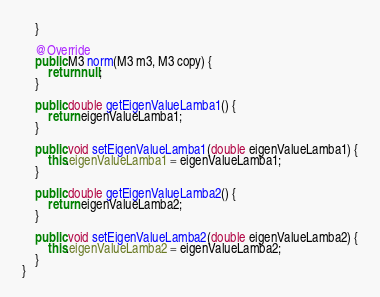Convert code to text. <code><loc_0><loc_0><loc_500><loc_500><_Java_>
    }

    @Override
    public M3 norm(M3 m3, M3 copy) {
        return null;
    }

    public double getEigenValueLamba1() {
        return eigenValueLamba1;
    }

    public void setEigenValueLamba1(double eigenValueLamba1) {
        this.eigenValueLamba1 = eigenValueLamba1;
    }

    public double getEigenValueLamba2() {
        return eigenValueLamba2;
    }

    public void setEigenValueLamba2(double eigenValueLamba2) {
        this.eigenValueLamba2 = eigenValueLamba2;
    }
}
</code> 